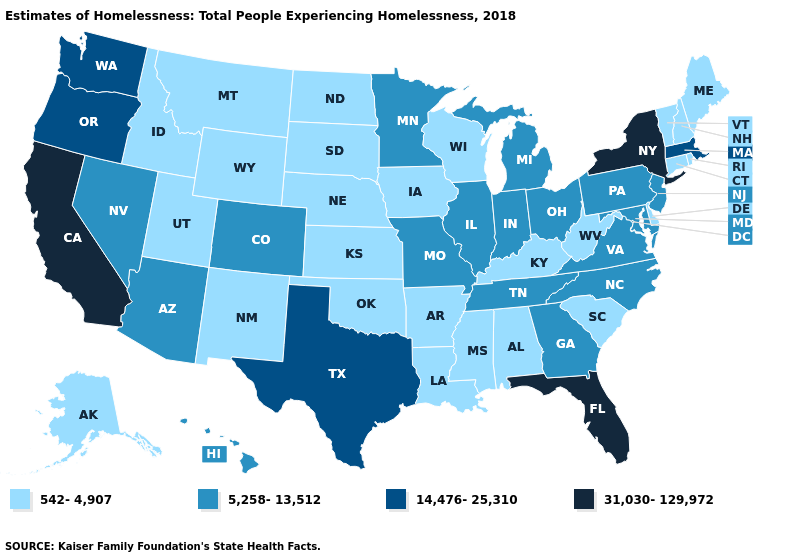What is the value of Arkansas?
Short answer required. 542-4,907. What is the value of Maryland?
Quick response, please. 5,258-13,512. What is the value of North Dakota?
Be succinct. 542-4,907. Name the states that have a value in the range 5,258-13,512?
Quick response, please. Arizona, Colorado, Georgia, Hawaii, Illinois, Indiana, Maryland, Michigan, Minnesota, Missouri, Nevada, New Jersey, North Carolina, Ohio, Pennsylvania, Tennessee, Virginia. What is the lowest value in the USA?
Write a very short answer. 542-4,907. Among the states that border New Mexico , which have the lowest value?
Give a very brief answer. Oklahoma, Utah. What is the value of Nevada?
Short answer required. 5,258-13,512. What is the value of Nevada?
Quick response, please. 5,258-13,512. Which states have the lowest value in the USA?
Be succinct. Alabama, Alaska, Arkansas, Connecticut, Delaware, Idaho, Iowa, Kansas, Kentucky, Louisiana, Maine, Mississippi, Montana, Nebraska, New Hampshire, New Mexico, North Dakota, Oklahoma, Rhode Island, South Carolina, South Dakota, Utah, Vermont, West Virginia, Wisconsin, Wyoming. Among the states that border Missouri , does Nebraska have the lowest value?
Write a very short answer. Yes. What is the value of Massachusetts?
Keep it brief. 14,476-25,310. Does the first symbol in the legend represent the smallest category?
Be succinct. Yes. What is the value of Alaska?
Keep it brief. 542-4,907. How many symbols are there in the legend?
Give a very brief answer. 4. Does Oklahoma have the highest value in the South?
Write a very short answer. No. 